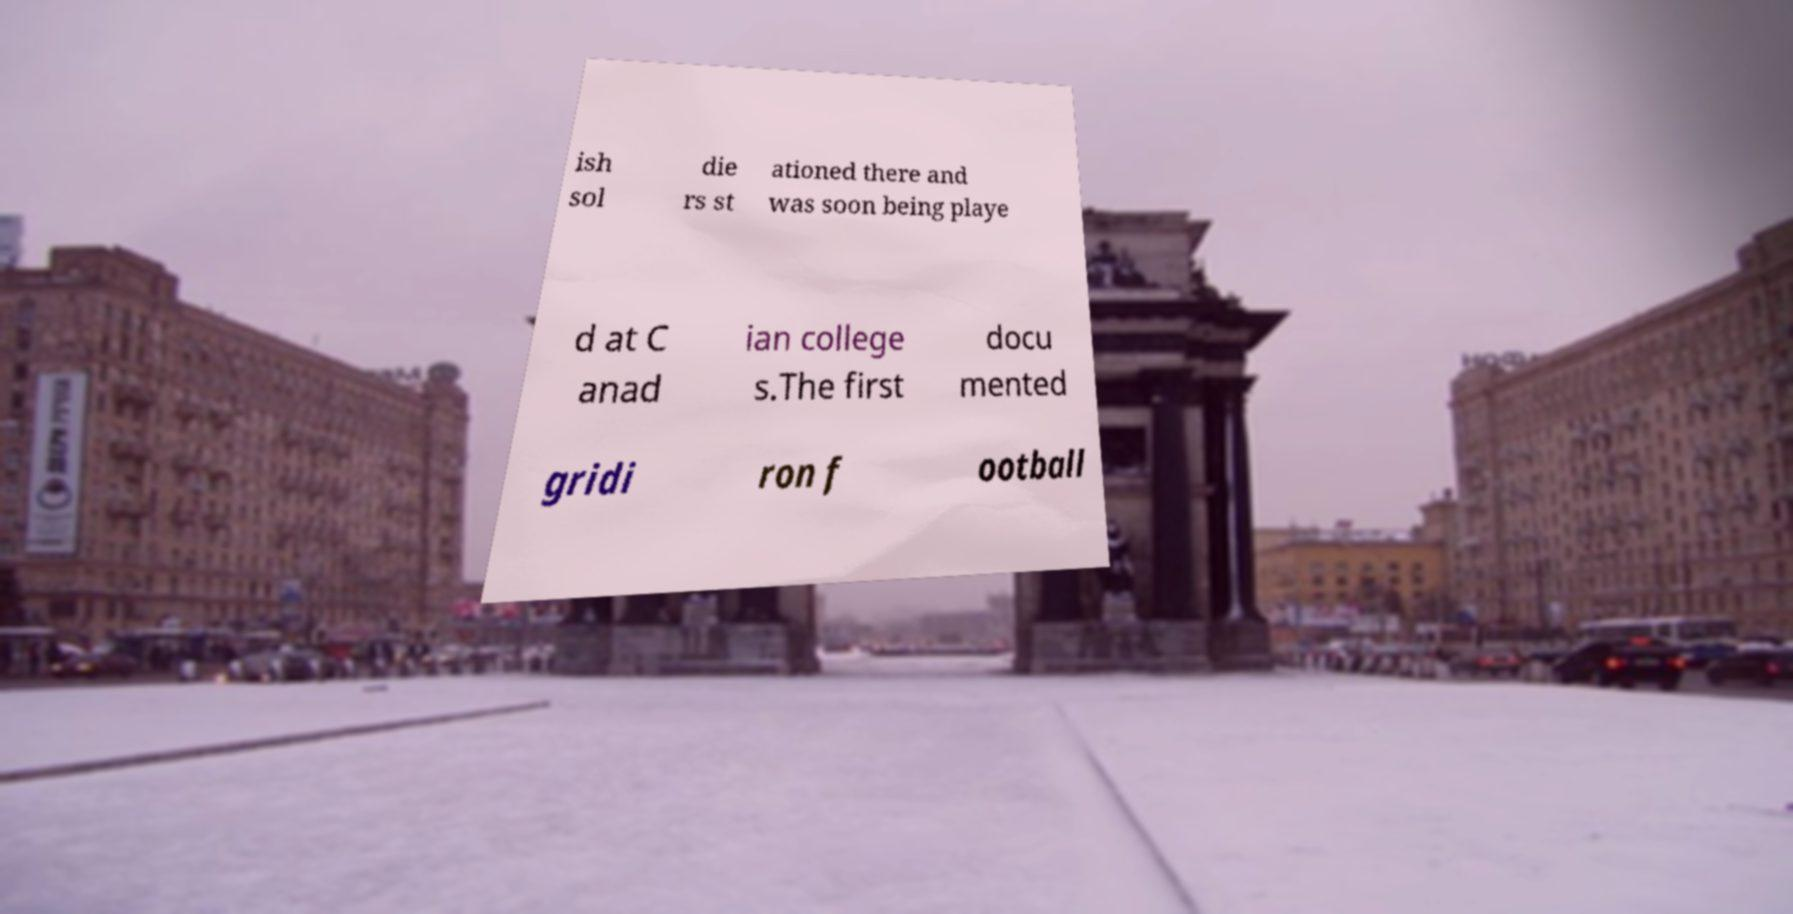Can you read and provide the text displayed in the image?This photo seems to have some interesting text. Can you extract and type it out for me? ish sol die rs st ationed there and was soon being playe d at C anad ian college s.The first docu mented gridi ron f ootball 